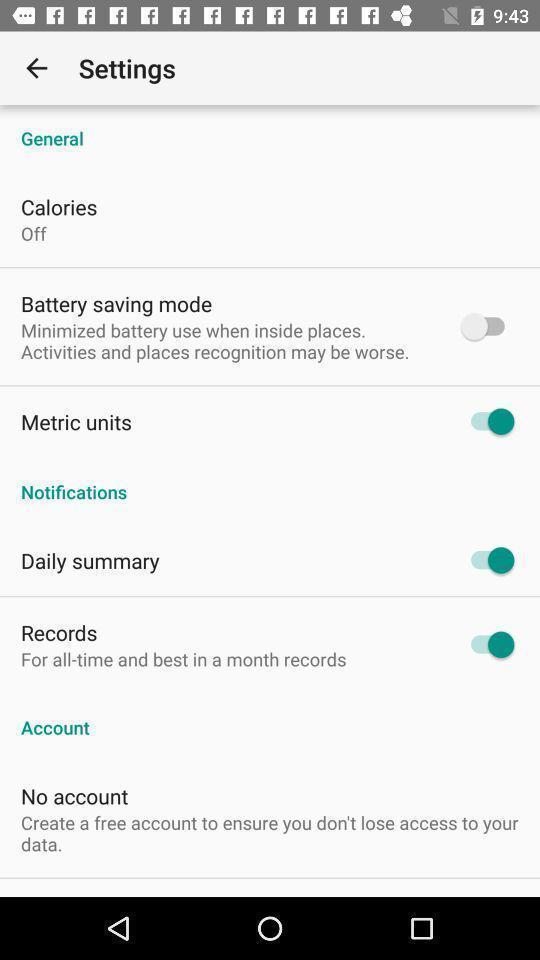Summarize the main components in this picture. Screen displaying the settings page. 